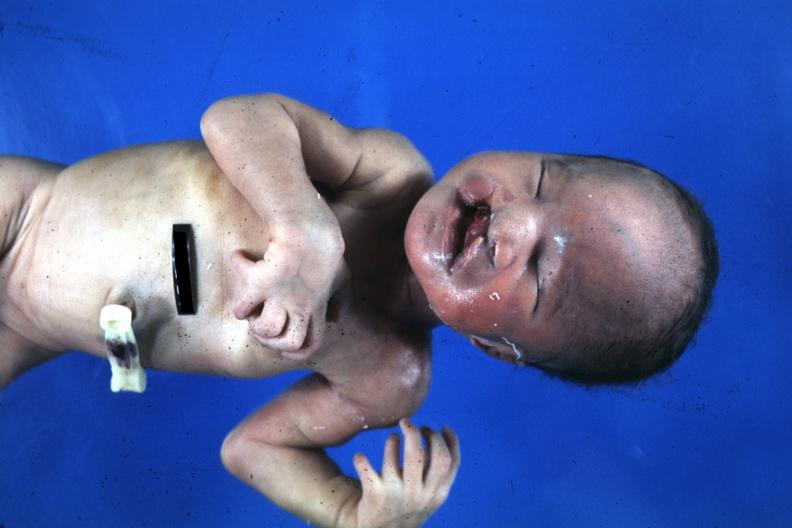s face present?
Answer the question using a single word or phrase. Yes 